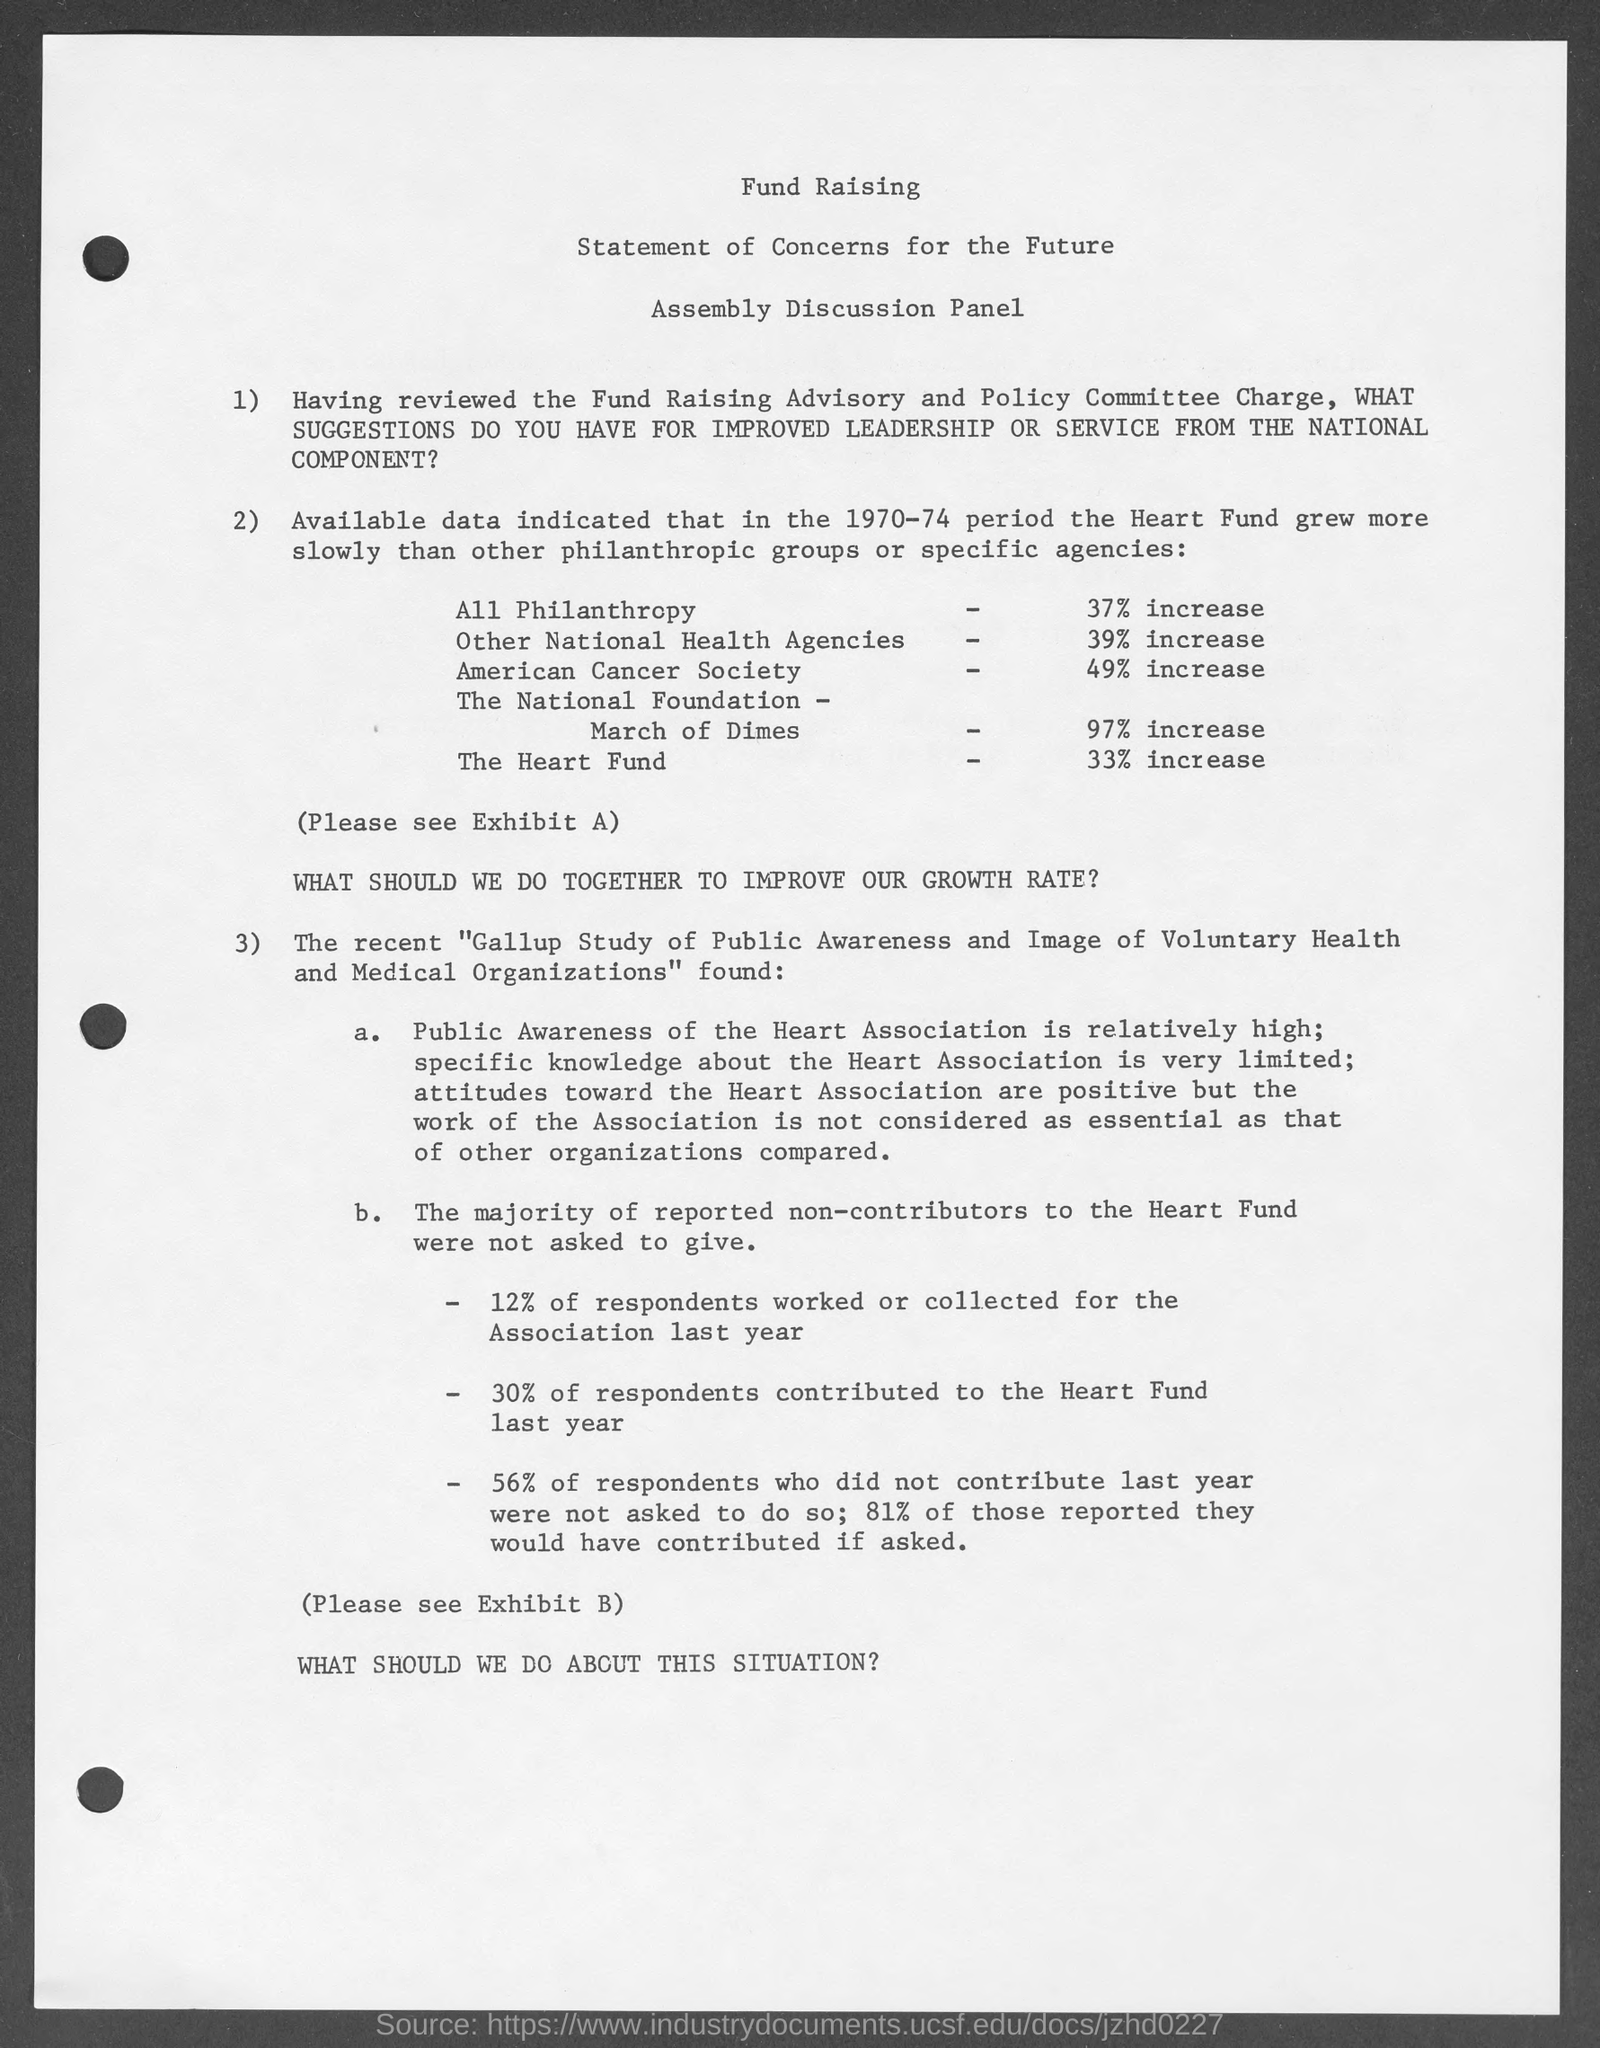List a handful of essential elements in this visual. The heart fund has experienced a 33% increase. The document's first title is "Fund Raising. The American Cancer Society has experienced a 49% increase in cases. According to the data, there has been a 37% increase in all philanthropy. 